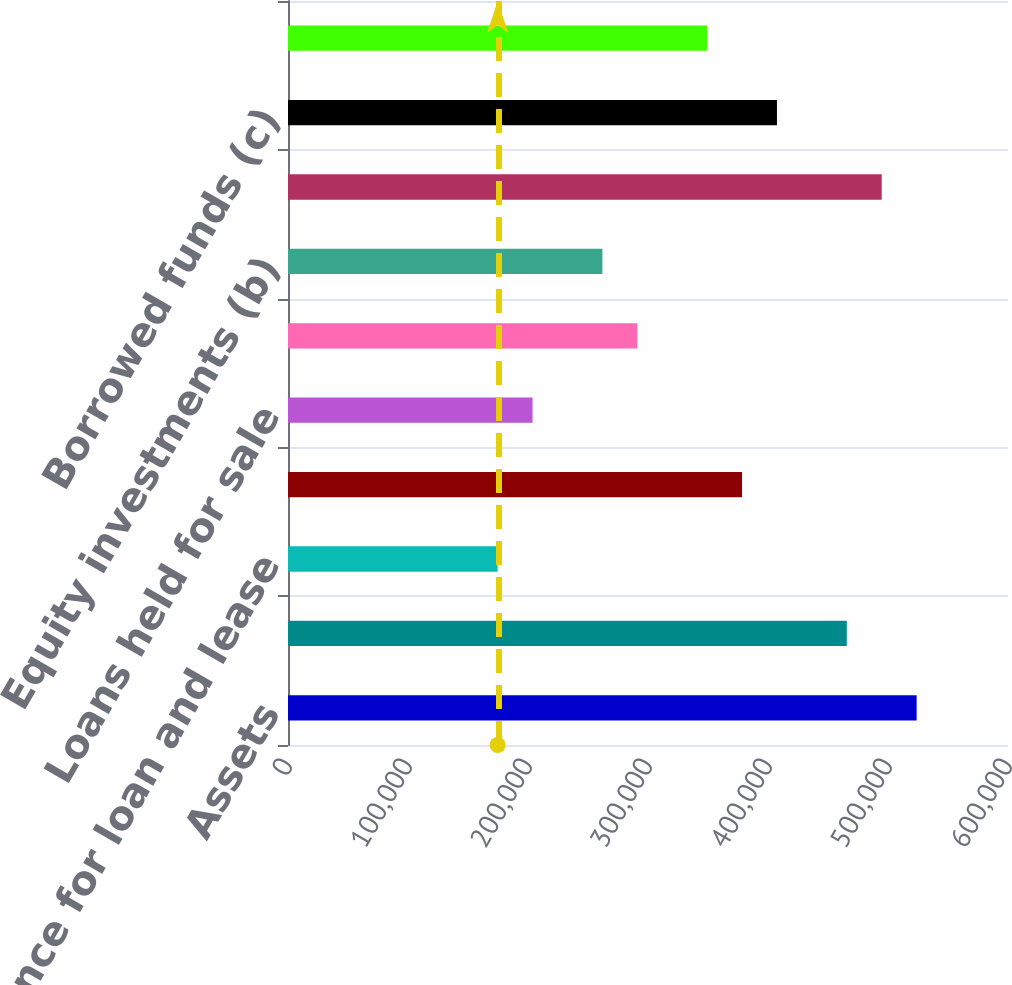Convert chart. <chart><loc_0><loc_0><loc_500><loc_500><bar_chart><fcel>Assets<fcel>Loans<fcel>Allowance for loan and lease<fcel>Investment securities<fcel>Loans held for sale<fcel>Goodwill<fcel>Equity investments (b)<fcel>Deposits<fcel>Borrowed funds (c)<fcel>Shareholders' equity<nl><fcel>523858<fcel>465664<fcel>174693<fcel>378372<fcel>203790<fcel>291081<fcel>261984<fcel>494761<fcel>407469<fcel>349275<nl></chart> 